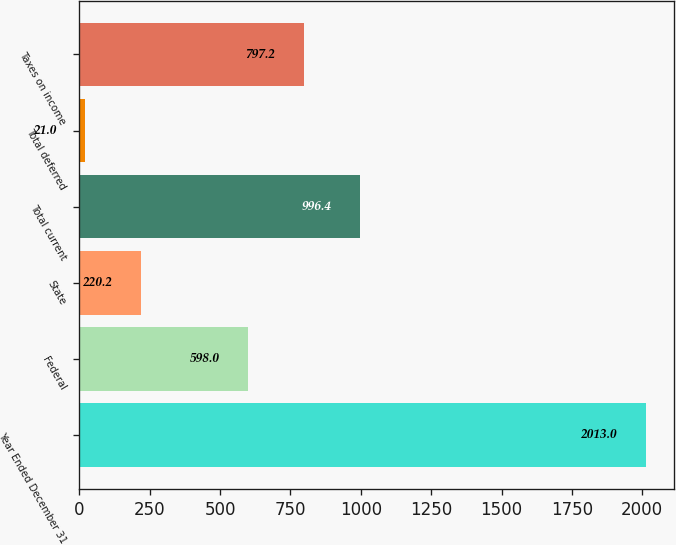Convert chart. <chart><loc_0><loc_0><loc_500><loc_500><bar_chart><fcel>Year Ended December 31<fcel>Federal<fcel>State<fcel>Total current<fcel>Total deferred<fcel>Taxes on income<nl><fcel>2013<fcel>598<fcel>220.2<fcel>996.4<fcel>21<fcel>797.2<nl></chart> 